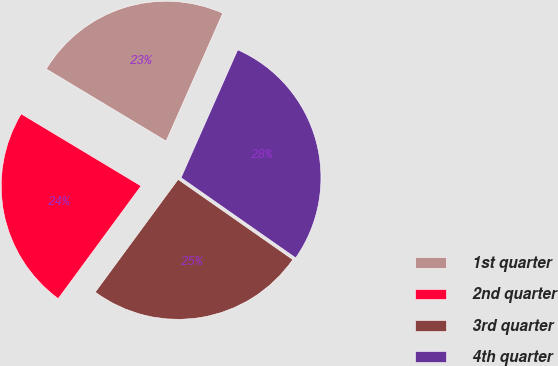Convert chart to OTSL. <chart><loc_0><loc_0><loc_500><loc_500><pie_chart><fcel>1st quarter<fcel>2nd quarter<fcel>3rd quarter<fcel>4th quarter<nl><fcel>23.02%<fcel>23.53%<fcel>25.38%<fcel>28.08%<nl></chart> 